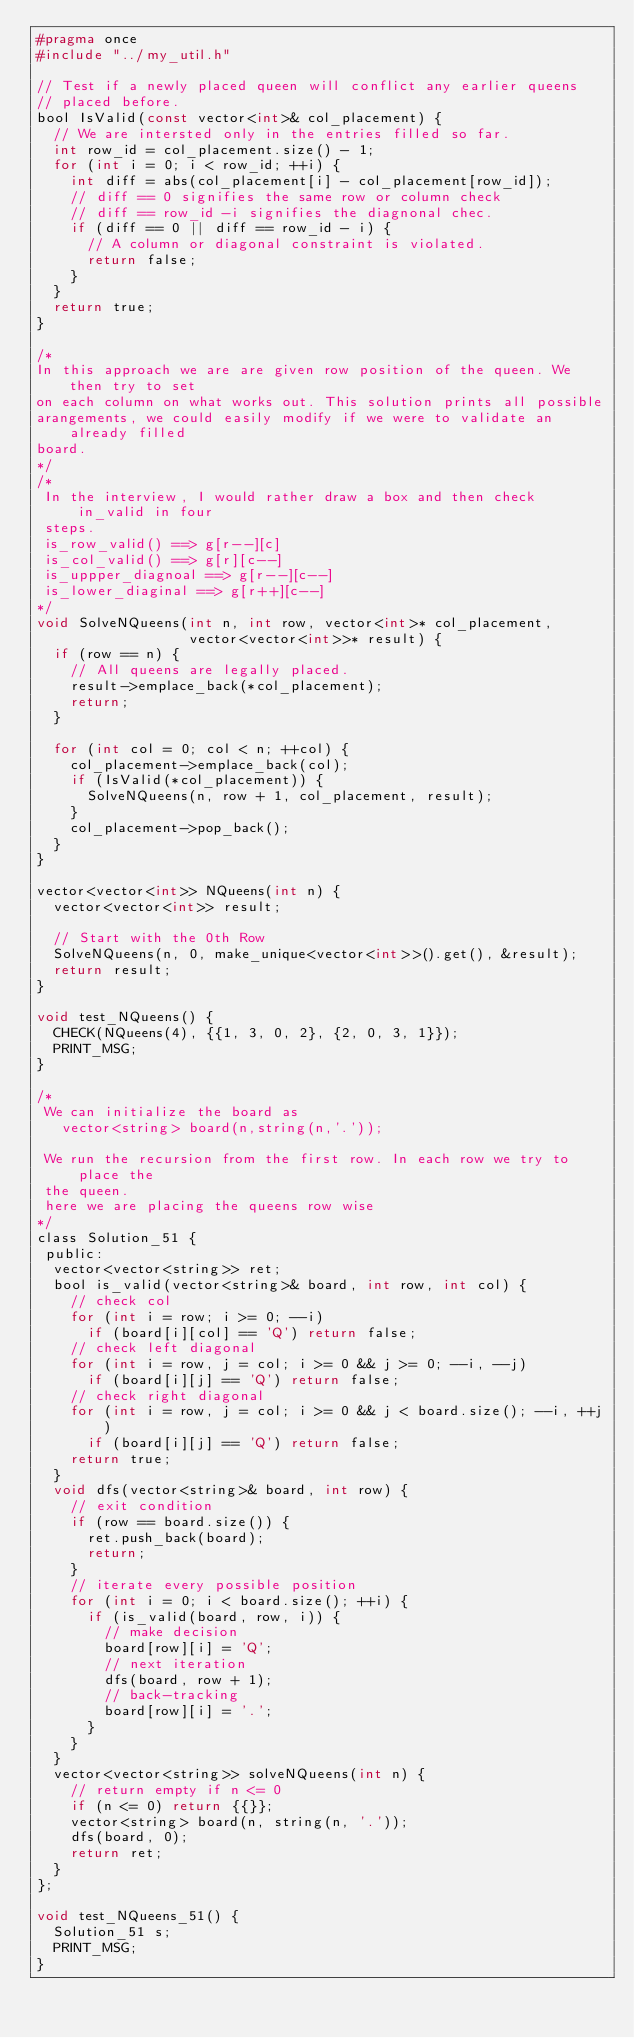Convert code to text. <code><loc_0><loc_0><loc_500><loc_500><_C_>#pragma once
#include "../my_util.h"

// Test if a newly placed queen will conflict any earlier queens
// placed before.
bool IsValid(const vector<int>& col_placement) {
  // We are intersted only in the entries filled so far.
  int row_id = col_placement.size() - 1;
  for (int i = 0; i < row_id; ++i) {
    int diff = abs(col_placement[i] - col_placement[row_id]);
    // diff == 0 signifies the same row or column check
    // diff == row_id -i signifies the diagnonal chec.
    if (diff == 0 || diff == row_id - i) {
      // A column or diagonal constraint is violated.
      return false;
    }
  }
  return true;
}

/*
In this approach we are are given row position of the queen. We then try to set
on each column on what works out. This solution prints all possible
arangements, we could easily modify if we were to validate an already filled
board.
*/
/*
 In the interview, I would rather draw a box and then check in_valid in four
 steps.
 is_row_valid() ==> g[r--][c]
 is_col_valid() ==> g[r][c--]
 is_uppper_diagnoal ==> g[r--][c--]
 is_lower_diaginal ==> g[r++][c--]
*/
void SolveNQueens(int n, int row, vector<int>* col_placement,
                  vector<vector<int>>* result) {
  if (row == n) {
    // All queens are legally placed.
    result->emplace_back(*col_placement);
    return;
  }

  for (int col = 0; col < n; ++col) {
    col_placement->emplace_back(col);
    if (IsValid(*col_placement)) {
      SolveNQueens(n, row + 1, col_placement, result);
    }
    col_placement->pop_back();
  }
}

vector<vector<int>> NQueens(int n) {
  vector<vector<int>> result;

  // Start with the 0th Row
  SolveNQueens(n, 0, make_unique<vector<int>>().get(), &result);
  return result;
}

void test_NQueens() {
  CHECK(NQueens(4), {{1, 3, 0, 2}, {2, 0, 3, 1}});
  PRINT_MSG;
}

/*
 We can initialize the board as
   vector<string> board(n,string(n,'.'));

 We run the recursion from the first row. In each row we try to place the
 the queen.
 here we are placing the queens row wise
*/
class Solution_51 {
 public:
  vector<vector<string>> ret;
  bool is_valid(vector<string>& board, int row, int col) {
    // check col
    for (int i = row; i >= 0; --i)
      if (board[i][col] == 'Q') return false;
    // check left diagonal
    for (int i = row, j = col; i >= 0 && j >= 0; --i, --j)
      if (board[i][j] == 'Q') return false;
    // check right diagonal
    for (int i = row, j = col; i >= 0 && j < board.size(); --i, ++j)
      if (board[i][j] == 'Q') return false;
    return true;
  }
  void dfs(vector<string>& board, int row) {
    // exit condition
    if (row == board.size()) {
      ret.push_back(board);
      return;
    }
    // iterate every possible position
    for (int i = 0; i < board.size(); ++i) {
      if (is_valid(board, row, i)) {
        // make decision
        board[row][i] = 'Q';
        // next iteration
        dfs(board, row + 1);
        // back-tracking
        board[row][i] = '.';
      }
    }
  }
  vector<vector<string>> solveNQueens(int n) {
    // return empty if n <= 0
    if (n <= 0) return {{}};
    vector<string> board(n, string(n, '.'));
    dfs(board, 0);
    return ret;
  }
};

void test_NQueens_51() {
  Solution_51 s;
  PRINT_MSG;
}</code> 